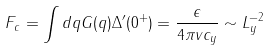<formula> <loc_0><loc_0><loc_500><loc_500>F _ { c } = \int d q G ( q ) \Delta ^ { \prime } ( 0 ^ { + } ) = \frac { \epsilon } { 4 \pi v c _ { y } } \sim L _ { y } ^ { - 2 }</formula> 